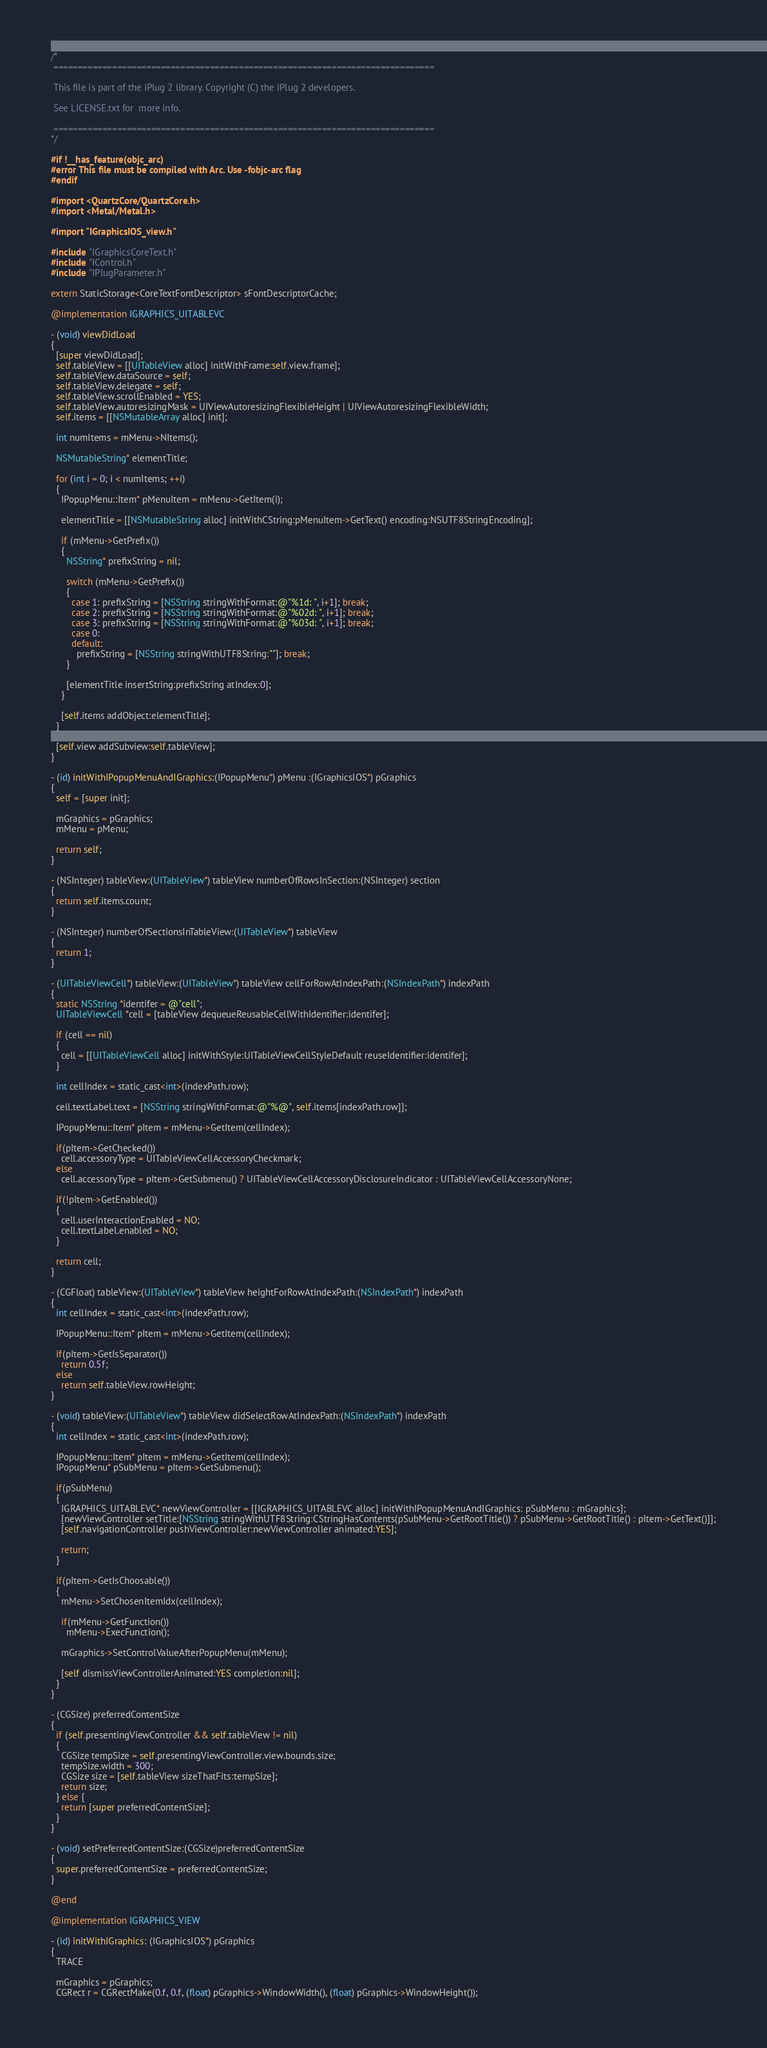<code> <loc_0><loc_0><loc_500><loc_500><_ObjectiveC_>/*
 ==============================================================================

 This file is part of the iPlug 2 library. Copyright (C) the iPlug 2 developers.

 See LICENSE.txt for  more info.

 ==============================================================================
*/

#if !__has_feature(objc_arc)
#error This file must be compiled with Arc. Use -fobjc-arc flag
#endif

#import <QuartzCore/QuartzCore.h>
#import <Metal/Metal.h>

#import "IGraphicsIOS_view.h"

#include "IGraphicsCoreText.h"
#include "IControl.h"
#include "IPlugParameter.h"

extern StaticStorage<CoreTextFontDescriptor> sFontDescriptorCache;

@implementation IGRAPHICS_UITABLEVC

- (void) viewDidLoad
{
  [super viewDidLoad];
  self.tableView = [[UITableView alloc] initWithFrame:self.view.frame];
  self.tableView.dataSource = self;
  self.tableView.delegate = self;
  self.tableView.scrollEnabled = YES;
  self.tableView.autoresizingMask = UIViewAutoresizingFlexibleHeight | UIViewAutoresizingFlexibleWidth;
  self.items = [[NSMutableArray alloc] init];
  
  int numItems = mMenu->NItems();

  NSMutableString* elementTitle;
  
  for (int i = 0; i < numItems; ++i)
  {
    IPopupMenu::Item* pMenuItem = mMenu->GetItem(i);

    elementTitle = [[NSMutableString alloc] initWithCString:pMenuItem->GetText() encoding:NSUTF8StringEncoding];

    if (mMenu->GetPrefix())
    {
      NSString* prefixString = nil;

      switch (mMenu->GetPrefix())
      {
        case 1: prefixString = [NSString stringWithFormat:@"%1d: ", i+1]; break;
        case 2: prefixString = [NSString stringWithFormat:@"%02d: ", i+1]; break;
        case 3: prefixString = [NSString stringWithFormat:@"%03d: ", i+1]; break;
        case 0:
        default:
          prefixString = [NSString stringWithUTF8String:""]; break;
      }

      [elementTitle insertString:prefixString atIndex:0];
    }

    [self.items addObject:elementTitle];
  }
  
  [self.view addSubview:self.tableView];
}

- (id) initWithIPopupMenuAndIGraphics:(IPopupMenu*) pMenu :(IGraphicsIOS*) pGraphics
{
  self = [super init];
  
  mGraphics = pGraphics;
  mMenu = pMenu;
  
  return self;
}

- (NSInteger) tableView:(UITableView*) tableView numberOfRowsInSection:(NSInteger) section
{
  return self.items.count;
}

- (NSInteger) numberOfSectionsInTableView:(UITableView*) tableView
{
  return 1;
}

- (UITableViewCell*) tableView:(UITableView*) tableView cellForRowAtIndexPath:(NSIndexPath*) indexPath
{
  static NSString *identifer = @"cell";
  UITableViewCell *cell = [tableView dequeueReusableCellWithIdentifier:identifer];
  
  if (cell == nil)
  {
    cell = [[UITableViewCell alloc] initWithStyle:UITableViewCellStyleDefault reuseIdentifier:identifer];
  }
  
  int cellIndex = static_cast<int>(indexPath.row);
  
  cell.textLabel.text = [NSString stringWithFormat:@"%@", self.items[indexPath.row]];
  
  IPopupMenu::Item* pItem = mMenu->GetItem(cellIndex);
  
  if(pItem->GetChecked())
    cell.accessoryType = UITableViewCellAccessoryCheckmark;
  else
    cell.accessoryType = pItem->GetSubmenu() ? UITableViewCellAccessoryDisclosureIndicator : UITableViewCellAccessoryNone;

  if(!pItem->GetEnabled())
  {
    cell.userInteractionEnabled = NO;
    cell.textLabel.enabled = NO;
  }
  
  return cell;
}

- (CGFloat) tableView:(UITableView*) tableView heightForRowAtIndexPath:(NSIndexPath*) indexPath
{
  int cellIndex = static_cast<int>(indexPath.row);

  IPopupMenu::Item* pItem = mMenu->GetItem(cellIndex);

  if(pItem->GetIsSeparator())
    return 0.5f;
  else
    return self.tableView.rowHeight;
}

- (void) tableView:(UITableView*) tableView didSelectRowAtIndexPath:(NSIndexPath*) indexPath
{
  int cellIndex = static_cast<int>(indexPath.row);

  IPopupMenu::Item* pItem = mMenu->GetItem(cellIndex);
  IPopupMenu* pSubMenu = pItem->GetSubmenu();
  
  if(pSubMenu)
  {
    IGRAPHICS_UITABLEVC* newViewController = [[IGRAPHICS_UITABLEVC alloc] initWithIPopupMenuAndIGraphics: pSubMenu : mGraphics];
    [newViewController setTitle:[NSString stringWithUTF8String:CStringHasContents(pSubMenu->GetRootTitle()) ? pSubMenu->GetRootTitle() : pItem->GetText()]];
    [self.navigationController pushViewController:newViewController animated:YES];
    
    return;
  }

  if(pItem->GetIsChoosable())
  {
    mMenu->SetChosenItemIdx(cellIndex);
    
    if(mMenu->GetFunction())
      mMenu->ExecFunction();
    
    mGraphics->SetControlValueAfterPopupMenu(mMenu);
    
    [self dismissViewControllerAnimated:YES completion:nil];
  }
}

- (CGSize) preferredContentSize
{
  if (self.presentingViewController && self.tableView != nil)
  {
    CGSize tempSize = self.presentingViewController.view.bounds.size;
    tempSize.width = 300;
    CGSize size = [self.tableView sizeThatFits:tempSize];
    return size;
  } else {
    return [super preferredContentSize];
  }
}

- (void) setPreferredContentSize:(CGSize)preferredContentSize
{
  super.preferredContentSize = preferredContentSize;
}

@end

@implementation IGRAPHICS_VIEW

- (id) initWithIGraphics: (IGraphicsIOS*) pGraphics
{
  TRACE

  mGraphics = pGraphics;
  CGRect r = CGRectMake(0.f, 0.f, (float) pGraphics->WindowWidth(), (float) pGraphics->WindowHeight());</code> 